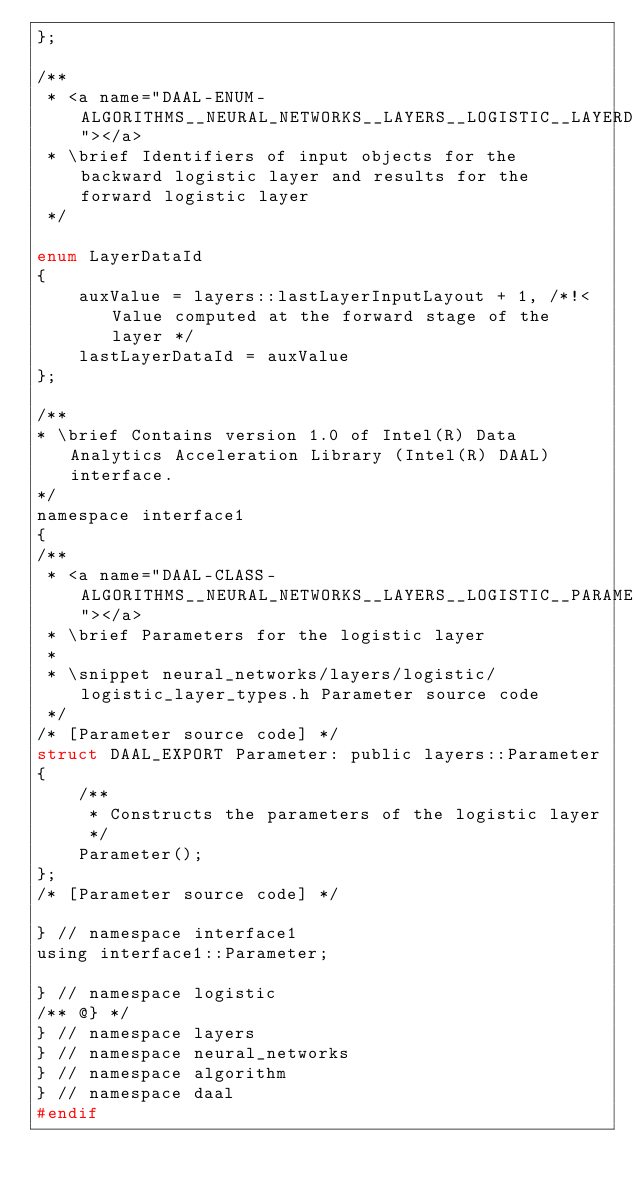Convert code to text. <code><loc_0><loc_0><loc_500><loc_500><_C_>};

/**
 * <a name="DAAL-ENUM-ALGORITHMS__NEURAL_NETWORKS__LAYERS__LOGISTIC__LAYERDATAID"></a>
 * \brief Identifiers of input objects for the backward logistic layer and results for the forward logistic layer
 */

enum LayerDataId
{
    auxValue = layers::lastLayerInputLayout + 1, /*!< Value computed at the forward stage of the layer */
    lastLayerDataId = auxValue
};

/**
* \brief Contains version 1.0 of Intel(R) Data Analytics Acceleration Library (Intel(R) DAAL) interface.
*/
namespace interface1
{
/**
 * <a name="DAAL-CLASS-ALGORITHMS__NEURAL_NETWORKS__LAYERS__LOGISTIC__PARAMETER"></a>
 * \brief Parameters for the logistic layer
 *
 * \snippet neural_networks/layers/logistic/logistic_layer_types.h Parameter source code
 */
/* [Parameter source code] */
struct DAAL_EXPORT Parameter: public layers::Parameter
{
    /**
     * Constructs the parameters of the logistic layer
     */
    Parameter();
};
/* [Parameter source code] */

} // namespace interface1
using interface1::Parameter;

} // namespace logistic
/** @} */
} // namespace layers
} // namespace neural_networks
} // namespace algorithm
} // namespace daal
#endif
</code> 